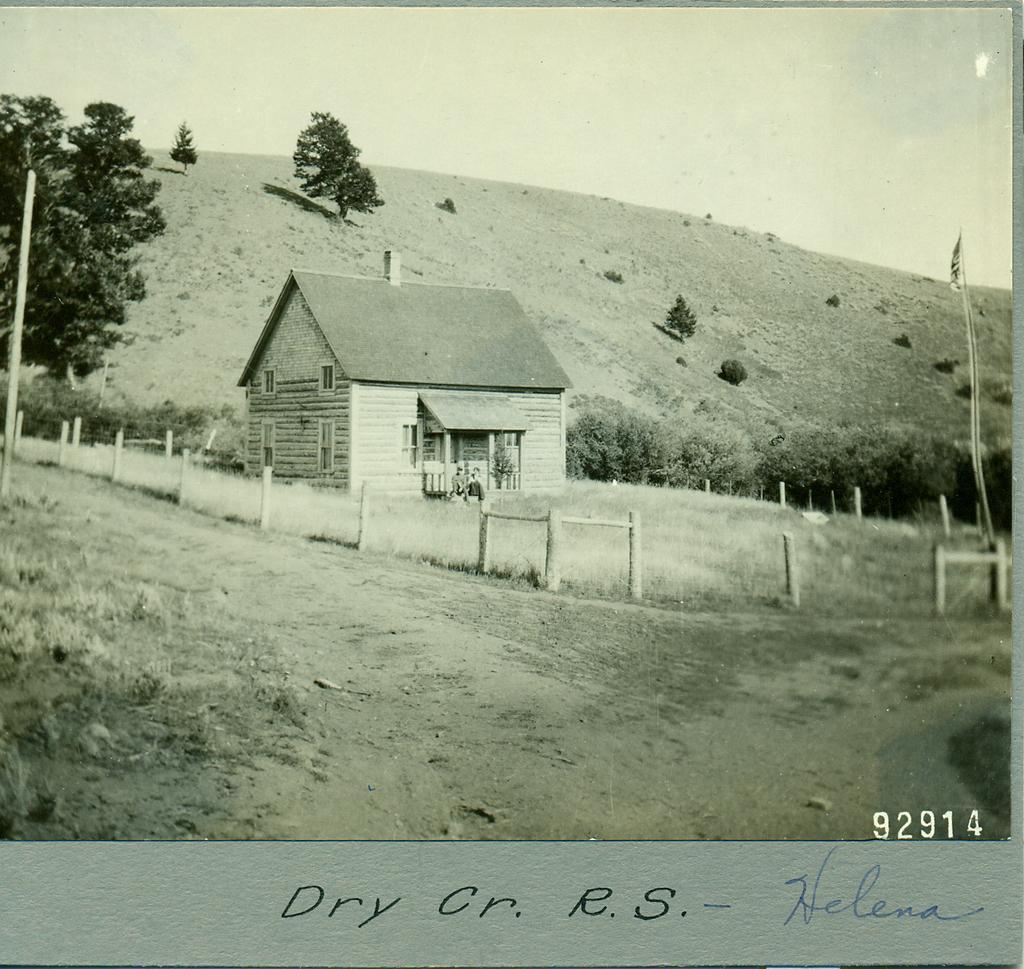In one or two sentences, can you explain what this image depicts? In this picture I can see a image on the paper, there is a house, grass, hill, there are wooden poles, plants, trees, and in the background there is the sky and there are numbers on the image, and there are words on the paper. 